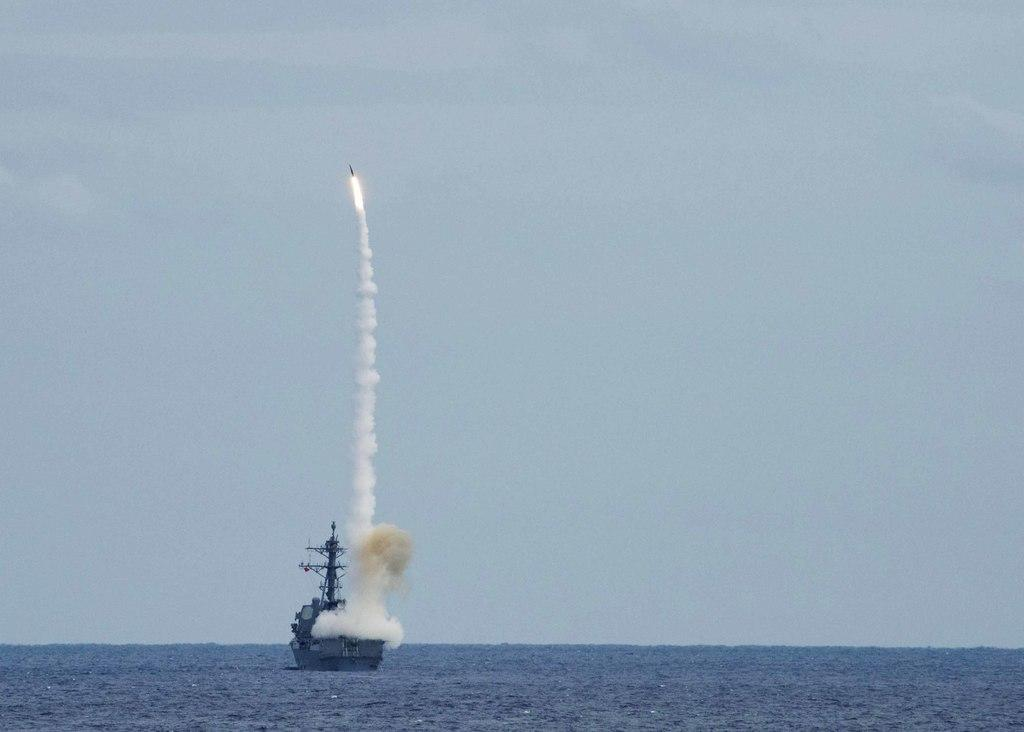What is the main subject of the image? The main subject of the image is a boat. What can be seen in the background of the image? There is water visible in the image. What other object is present in the image besides the boat? There is a rocket in the image. What is the source of the smoke in the image? The smoke is present in the image, likely due to the rocket. What part of the natural environment is visible in the image? The sky is visible in the image. What type of plate is being used to serve the coach in the image? There is no plate or coach present in the image. What hobbies are the people in the image engaged in? The image does not show any people, so their hobbies cannot be determined. 